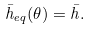Convert formula to latex. <formula><loc_0><loc_0><loc_500><loc_500>\bar { h } _ { e q } ( \theta ) = \bar { h } .</formula> 